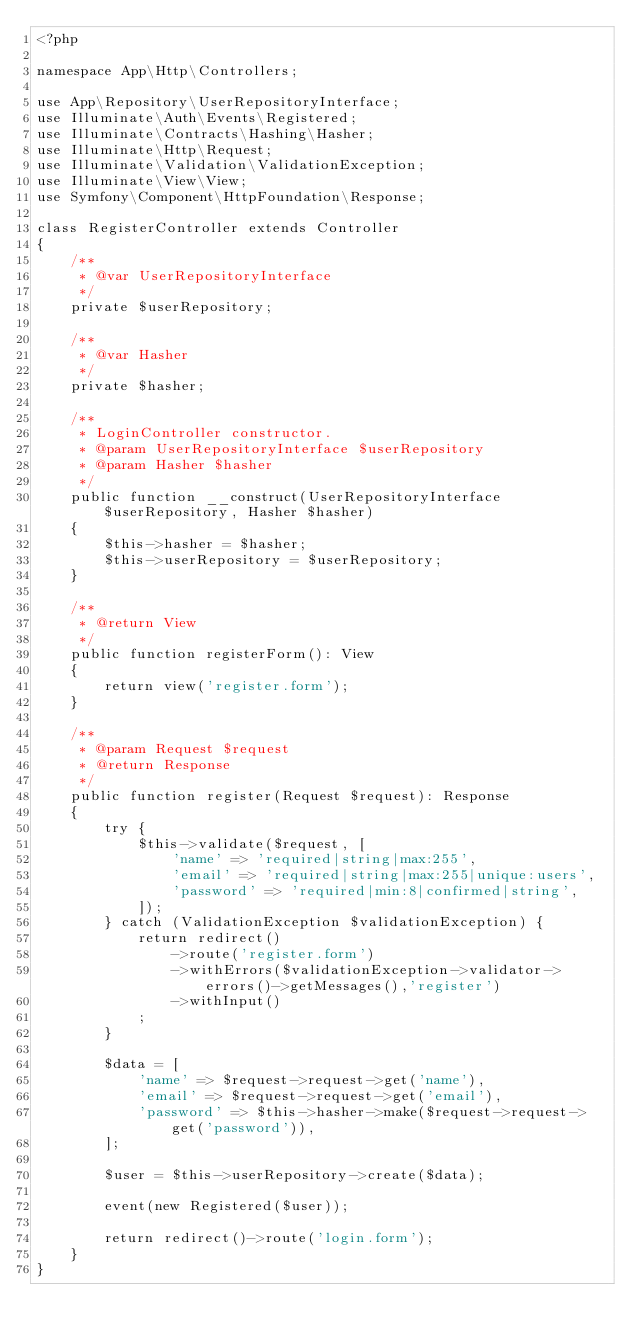<code> <loc_0><loc_0><loc_500><loc_500><_PHP_><?php

namespace App\Http\Controllers;

use App\Repository\UserRepositoryInterface;
use Illuminate\Auth\Events\Registered;
use Illuminate\Contracts\Hashing\Hasher;
use Illuminate\Http\Request;
use Illuminate\Validation\ValidationException;
use Illuminate\View\View;
use Symfony\Component\HttpFoundation\Response;

class RegisterController extends Controller
{
    /**
     * @var UserRepositoryInterface
     */
    private $userRepository;

    /**
     * @var Hasher
     */
    private $hasher;

    /**
     * LoginController constructor.
     * @param UserRepositoryInterface $userRepository
     * @param Hasher $hasher
     */
    public function __construct(UserRepositoryInterface $userRepository, Hasher $hasher)
    {
        $this->hasher = $hasher;
        $this->userRepository = $userRepository;
    }

    /**
     * @return View
     */
    public function registerForm(): View
    {
        return view('register.form');
    }

    /**
     * @param Request $request
     * @return Response
     */
    public function register(Request $request): Response
    {
        try {
            $this->validate($request, [
                'name' => 'required|string|max:255',
                'email' => 'required|string|max:255|unique:users',
                'password' => 'required|min:8|confirmed|string',
            ]);
        } catch (ValidationException $validationException) {
            return redirect()
                ->route('register.form')
                ->withErrors($validationException->validator->errors()->getMessages(),'register')
                ->withInput()
            ;
        }

        $data = [
            'name' => $request->request->get('name'),
            'email' => $request->request->get('email'),
            'password' => $this->hasher->make($request->request->get('password')),
        ];

        $user = $this->userRepository->create($data);

        event(new Registered($user));

        return redirect()->route('login.form');
    }
}
</code> 